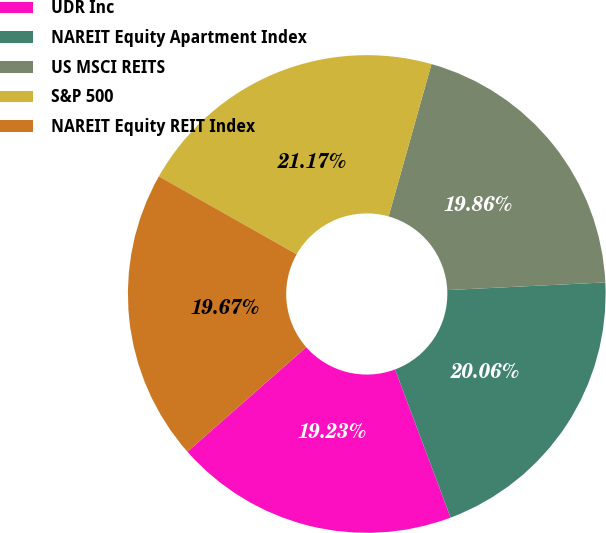<chart> <loc_0><loc_0><loc_500><loc_500><pie_chart><fcel>UDR Inc<fcel>NAREIT Equity Apartment Index<fcel>US MSCI REITS<fcel>S&P 500<fcel>NAREIT Equity REIT Index<nl><fcel>19.23%<fcel>20.06%<fcel>19.86%<fcel>21.17%<fcel>19.67%<nl></chart> 